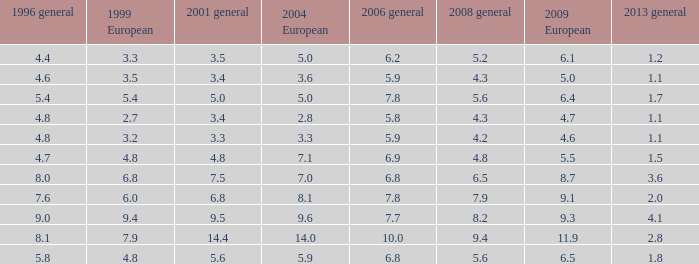3 and lesser than None. 